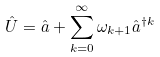<formula> <loc_0><loc_0><loc_500><loc_500>\hat { U } = \hat { a } + \sum _ { k = 0 } ^ { \infty } \omega _ { k + 1 } \hat { a } ^ { \dag k }</formula> 